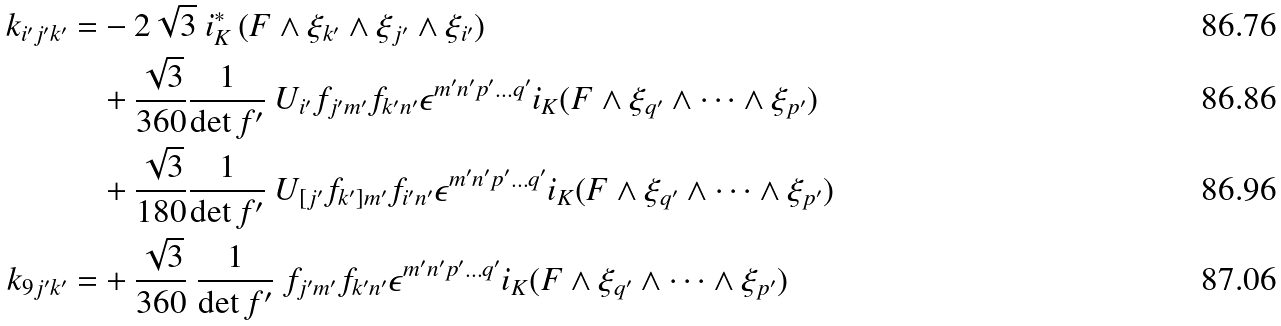<formula> <loc_0><loc_0><loc_500><loc_500>k _ { i ^ { \prime } j ^ { \prime } k ^ { \prime } } = & - 2 \sqrt { 3 } \ i _ { K } ^ { * } \, ( F \wedge \xi _ { k ^ { \prime } } \wedge \xi _ { j ^ { \prime } } \wedge \xi _ { i ^ { \prime } } ) \\ & + \frac { \sqrt { 3 } } { 3 6 0 } \frac { 1 } { \det f ^ { \prime } } \ U _ { i ^ { \prime } } f _ { j ^ { \prime } m ^ { \prime } } f _ { k ^ { \prime } n ^ { \prime } } \epsilon ^ { m ^ { \prime } n ^ { \prime } p ^ { \prime } \dots q ^ { \prime } } i _ { K } ( F \wedge \xi _ { q ^ { \prime } } \wedge \dots \wedge \xi _ { p ^ { \prime } } ) \\ & + \frac { \sqrt { 3 } } { 1 8 0 } \frac { 1 } { \det f ^ { \prime } } \ U _ { [ j ^ { \prime } } f _ { k ^ { \prime } ] m ^ { \prime } } f _ { i ^ { \prime } n ^ { \prime } } \epsilon ^ { m ^ { \prime } n ^ { \prime } p ^ { \prime } \dots q ^ { \prime } } i _ { K } ( F \wedge \xi _ { q ^ { \prime } } \wedge \dots \wedge \xi _ { p ^ { \prime } } ) \\ k _ { 9 j ^ { \prime } k ^ { \prime } } = & + \frac { \sqrt { 3 } } { 3 6 0 } \ \frac { 1 } { \det f ^ { \prime } } \ f _ { j ^ { \prime } m ^ { \prime } } f _ { k ^ { \prime } n ^ { \prime } } \epsilon ^ { m ^ { \prime } n ^ { \prime } p ^ { \prime } \dots q ^ { \prime } } i _ { K } ( F \wedge \xi _ { q ^ { \prime } } \wedge \dots \wedge \xi _ { p ^ { \prime } } )</formula> 